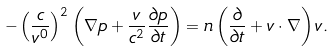Convert formula to latex. <formula><loc_0><loc_0><loc_500><loc_500>- \left ( \frac { c } { v ^ { 0 } } \right ) ^ { 2 } \left ( \nabla p + \frac { v } { c ^ { 2 } } \frac { \partial p } { \partial t } \right ) = n \left ( \frac { \partial } { \partial t } + { v } \cdot \nabla \right ) { v } .</formula> 